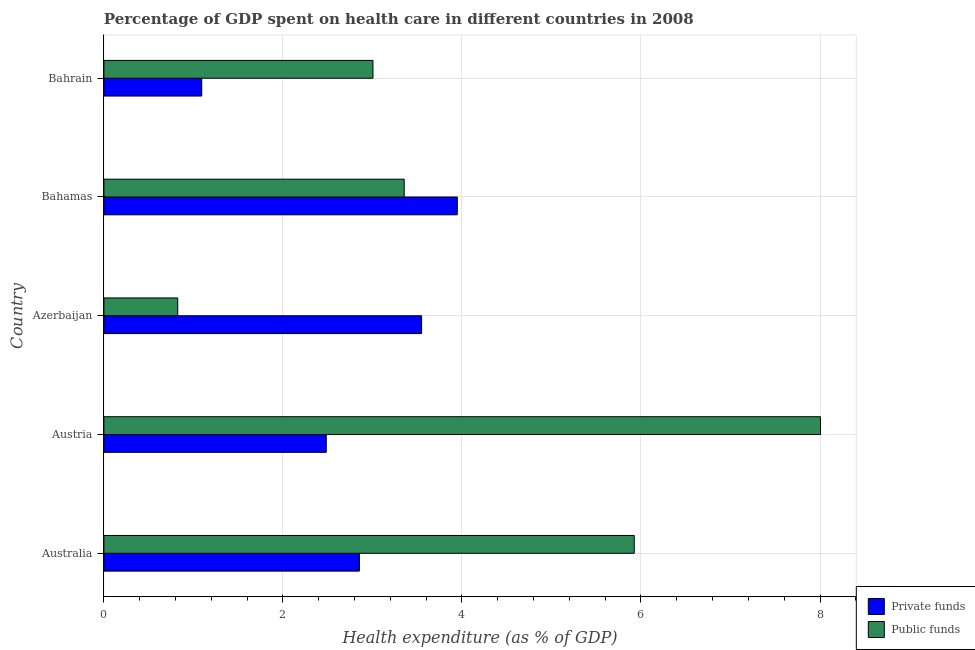How many groups of bars are there?
Your answer should be compact. 5. How many bars are there on the 5th tick from the bottom?
Provide a short and direct response. 2. What is the label of the 2nd group of bars from the top?
Provide a succinct answer. Bahamas. What is the amount of private funds spent in healthcare in Austria?
Your answer should be compact. 2.48. Across all countries, what is the maximum amount of private funds spent in healthcare?
Give a very brief answer. 3.95. Across all countries, what is the minimum amount of public funds spent in healthcare?
Offer a very short reply. 0.82. In which country was the amount of private funds spent in healthcare maximum?
Offer a terse response. Bahamas. In which country was the amount of public funds spent in healthcare minimum?
Offer a very short reply. Azerbaijan. What is the total amount of public funds spent in healthcare in the graph?
Offer a terse response. 21.12. What is the difference between the amount of private funds spent in healthcare in Australia and that in Bahrain?
Provide a succinct answer. 1.76. What is the difference between the amount of public funds spent in healthcare in Azerbaijan and the amount of private funds spent in healthcare in Bahamas?
Provide a succinct answer. -3.12. What is the average amount of public funds spent in healthcare per country?
Provide a short and direct response. 4.22. What is the difference between the amount of public funds spent in healthcare and amount of private funds spent in healthcare in Bahamas?
Your answer should be very brief. -0.59. In how many countries, is the amount of public funds spent in healthcare greater than 6 %?
Provide a short and direct response. 1. What is the ratio of the amount of public funds spent in healthcare in Azerbaijan to that in Bahamas?
Provide a succinct answer. 0.25. Is the difference between the amount of public funds spent in healthcare in Australia and Azerbaijan greater than the difference between the amount of private funds spent in healthcare in Australia and Azerbaijan?
Provide a succinct answer. Yes. What is the difference between the highest and the second highest amount of public funds spent in healthcare?
Provide a succinct answer. 2.08. What is the difference between the highest and the lowest amount of public funds spent in healthcare?
Provide a succinct answer. 7.18. In how many countries, is the amount of private funds spent in healthcare greater than the average amount of private funds spent in healthcare taken over all countries?
Offer a very short reply. 3. Is the sum of the amount of private funds spent in healthcare in Azerbaijan and Bahrain greater than the maximum amount of public funds spent in healthcare across all countries?
Give a very brief answer. No. What does the 2nd bar from the top in Austria represents?
Provide a short and direct response. Private funds. What does the 1st bar from the bottom in Bahrain represents?
Provide a succinct answer. Private funds. How many bars are there?
Make the answer very short. 10. How many countries are there in the graph?
Your response must be concise. 5. What is the difference between two consecutive major ticks on the X-axis?
Make the answer very short. 2. Are the values on the major ticks of X-axis written in scientific E-notation?
Ensure brevity in your answer.  No. How are the legend labels stacked?
Offer a terse response. Vertical. What is the title of the graph?
Provide a short and direct response. Percentage of GDP spent on health care in different countries in 2008. What is the label or title of the X-axis?
Make the answer very short. Health expenditure (as % of GDP). What is the Health expenditure (as % of GDP) of Private funds in Australia?
Make the answer very short. 2.85. What is the Health expenditure (as % of GDP) in Public funds in Australia?
Your response must be concise. 5.92. What is the Health expenditure (as % of GDP) in Private funds in Austria?
Keep it short and to the point. 2.48. What is the Health expenditure (as % of GDP) of Public funds in Austria?
Keep it short and to the point. 8.01. What is the Health expenditure (as % of GDP) of Private funds in Azerbaijan?
Your answer should be very brief. 3.55. What is the Health expenditure (as % of GDP) of Public funds in Azerbaijan?
Your answer should be compact. 0.82. What is the Health expenditure (as % of GDP) of Private funds in Bahamas?
Your response must be concise. 3.95. What is the Health expenditure (as % of GDP) of Public funds in Bahamas?
Your response must be concise. 3.35. What is the Health expenditure (as % of GDP) of Private funds in Bahrain?
Give a very brief answer. 1.09. What is the Health expenditure (as % of GDP) in Public funds in Bahrain?
Keep it short and to the point. 3.01. Across all countries, what is the maximum Health expenditure (as % of GDP) of Private funds?
Your answer should be very brief. 3.95. Across all countries, what is the maximum Health expenditure (as % of GDP) of Public funds?
Offer a terse response. 8.01. Across all countries, what is the minimum Health expenditure (as % of GDP) of Private funds?
Provide a short and direct response. 1.09. Across all countries, what is the minimum Health expenditure (as % of GDP) of Public funds?
Ensure brevity in your answer.  0.82. What is the total Health expenditure (as % of GDP) of Private funds in the graph?
Provide a succinct answer. 13.93. What is the total Health expenditure (as % of GDP) of Public funds in the graph?
Provide a short and direct response. 21.12. What is the difference between the Health expenditure (as % of GDP) in Private funds in Australia and that in Austria?
Ensure brevity in your answer.  0.37. What is the difference between the Health expenditure (as % of GDP) of Public funds in Australia and that in Austria?
Offer a terse response. -2.08. What is the difference between the Health expenditure (as % of GDP) of Private funds in Australia and that in Azerbaijan?
Your response must be concise. -0.69. What is the difference between the Health expenditure (as % of GDP) in Public funds in Australia and that in Azerbaijan?
Provide a succinct answer. 5.1. What is the difference between the Health expenditure (as % of GDP) in Private funds in Australia and that in Bahamas?
Offer a very short reply. -1.09. What is the difference between the Health expenditure (as % of GDP) of Public funds in Australia and that in Bahamas?
Offer a terse response. 2.57. What is the difference between the Health expenditure (as % of GDP) in Private funds in Australia and that in Bahrain?
Offer a terse response. 1.76. What is the difference between the Health expenditure (as % of GDP) of Public funds in Australia and that in Bahrain?
Keep it short and to the point. 2.92. What is the difference between the Health expenditure (as % of GDP) of Private funds in Austria and that in Azerbaijan?
Offer a very short reply. -1.07. What is the difference between the Health expenditure (as % of GDP) in Public funds in Austria and that in Azerbaijan?
Make the answer very short. 7.18. What is the difference between the Health expenditure (as % of GDP) in Private funds in Austria and that in Bahamas?
Offer a very short reply. -1.46. What is the difference between the Health expenditure (as % of GDP) in Public funds in Austria and that in Bahamas?
Your answer should be compact. 4.65. What is the difference between the Health expenditure (as % of GDP) of Private funds in Austria and that in Bahrain?
Provide a short and direct response. 1.39. What is the difference between the Health expenditure (as % of GDP) in Public funds in Austria and that in Bahrain?
Keep it short and to the point. 5. What is the difference between the Health expenditure (as % of GDP) of Private funds in Azerbaijan and that in Bahamas?
Provide a succinct answer. -0.4. What is the difference between the Health expenditure (as % of GDP) of Public funds in Azerbaijan and that in Bahamas?
Your answer should be very brief. -2.53. What is the difference between the Health expenditure (as % of GDP) of Private funds in Azerbaijan and that in Bahrain?
Keep it short and to the point. 2.46. What is the difference between the Health expenditure (as % of GDP) in Public funds in Azerbaijan and that in Bahrain?
Offer a terse response. -2.18. What is the difference between the Health expenditure (as % of GDP) in Private funds in Bahamas and that in Bahrain?
Offer a terse response. 2.85. What is the difference between the Health expenditure (as % of GDP) of Public funds in Bahamas and that in Bahrain?
Your answer should be compact. 0.35. What is the difference between the Health expenditure (as % of GDP) in Private funds in Australia and the Health expenditure (as % of GDP) in Public funds in Austria?
Ensure brevity in your answer.  -5.15. What is the difference between the Health expenditure (as % of GDP) in Private funds in Australia and the Health expenditure (as % of GDP) in Public funds in Azerbaijan?
Provide a succinct answer. 2.03. What is the difference between the Health expenditure (as % of GDP) in Private funds in Australia and the Health expenditure (as % of GDP) in Public funds in Bahamas?
Give a very brief answer. -0.5. What is the difference between the Health expenditure (as % of GDP) in Private funds in Australia and the Health expenditure (as % of GDP) in Public funds in Bahrain?
Make the answer very short. -0.15. What is the difference between the Health expenditure (as % of GDP) in Private funds in Austria and the Health expenditure (as % of GDP) in Public funds in Azerbaijan?
Provide a short and direct response. 1.66. What is the difference between the Health expenditure (as % of GDP) of Private funds in Austria and the Health expenditure (as % of GDP) of Public funds in Bahamas?
Give a very brief answer. -0.87. What is the difference between the Health expenditure (as % of GDP) in Private funds in Austria and the Health expenditure (as % of GDP) in Public funds in Bahrain?
Your answer should be compact. -0.52. What is the difference between the Health expenditure (as % of GDP) in Private funds in Azerbaijan and the Health expenditure (as % of GDP) in Public funds in Bahamas?
Your response must be concise. 0.19. What is the difference between the Health expenditure (as % of GDP) of Private funds in Azerbaijan and the Health expenditure (as % of GDP) of Public funds in Bahrain?
Provide a succinct answer. 0.54. What is the difference between the Health expenditure (as % of GDP) of Private funds in Bahamas and the Health expenditure (as % of GDP) of Public funds in Bahrain?
Offer a very short reply. 0.94. What is the average Health expenditure (as % of GDP) of Private funds per country?
Offer a very short reply. 2.79. What is the average Health expenditure (as % of GDP) of Public funds per country?
Provide a succinct answer. 4.22. What is the difference between the Health expenditure (as % of GDP) in Private funds and Health expenditure (as % of GDP) in Public funds in Australia?
Provide a short and direct response. -3.07. What is the difference between the Health expenditure (as % of GDP) of Private funds and Health expenditure (as % of GDP) of Public funds in Austria?
Provide a succinct answer. -5.52. What is the difference between the Health expenditure (as % of GDP) of Private funds and Health expenditure (as % of GDP) of Public funds in Azerbaijan?
Give a very brief answer. 2.72. What is the difference between the Health expenditure (as % of GDP) of Private funds and Health expenditure (as % of GDP) of Public funds in Bahamas?
Make the answer very short. 0.59. What is the difference between the Health expenditure (as % of GDP) of Private funds and Health expenditure (as % of GDP) of Public funds in Bahrain?
Your answer should be compact. -1.91. What is the ratio of the Health expenditure (as % of GDP) of Private funds in Australia to that in Austria?
Make the answer very short. 1.15. What is the ratio of the Health expenditure (as % of GDP) of Public funds in Australia to that in Austria?
Give a very brief answer. 0.74. What is the ratio of the Health expenditure (as % of GDP) of Private funds in Australia to that in Azerbaijan?
Provide a short and direct response. 0.8. What is the ratio of the Health expenditure (as % of GDP) in Public funds in Australia to that in Azerbaijan?
Make the answer very short. 7.18. What is the ratio of the Health expenditure (as % of GDP) of Private funds in Australia to that in Bahamas?
Your response must be concise. 0.72. What is the ratio of the Health expenditure (as % of GDP) of Public funds in Australia to that in Bahamas?
Ensure brevity in your answer.  1.77. What is the ratio of the Health expenditure (as % of GDP) in Private funds in Australia to that in Bahrain?
Your answer should be compact. 2.61. What is the ratio of the Health expenditure (as % of GDP) in Public funds in Australia to that in Bahrain?
Ensure brevity in your answer.  1.97. What is the ratio of the Health expenditure (as % of GDP) of Private funds in Austria to that in Azerbaijan?
Your answer should be compact. 0.7. What is the ratio of the Health expenditure (as % of GDP) of Public funds in Austria to that in Azerbaijan?
Provide a short and direct response. 9.71. What is the ratio of the Health expenditure (as % of GDP) of Private funds in Austria to that in Bahamas?
Offer a very short reply. 0.63. What is the ratio of the Health expenditure (as % of GDP) of Public funds in Austria to that in Bahamas?
Your answer should be compact. 2.39. What is the ratio of the Health expenditure (as % of GDP) of Private funds in Austria to that in Bahrain?
Offer a terse response. 2.27. What is the ratio of the Health expenditure (as % of GDP) in Public funds in Austria to that in Bahrain?
Keep it short and to the point. 2.66. What is the ratio of the Health expenditure (as % of GDP) in Private funds in Azerbaijan to that in Bahamas?
Your answer should be very brief. 0.9. What is the ratio of the Health expenditure (as % of GDP) in Public funds in Azerbaijan to that in Bahamas?
Provide a short and direct response. 0.25. What is the ratio of the Health expenditure (as % of GDP) of Private funds in Azerbaijan to that in Bahrain?
Offer a very short reply. 3.25. What is the ratio of the Health expenditure (as % of GDP) in Public funds in Azerbaijan to that in Bahrain?
Ensure brevity in your answer.  0.27. What is the ratio of the Health expenditure (as % of GDP) in Private funds in Bahamas to that in Bahrain?
Your response must be concise. 3.61. What is the ratio of the Health expenditure (as % of GDP) of Public funds in Bahamas to that in Bahrain?
Ensure brevity in your answer.  1.12. What is the difference between the highest and the second highest Health expenditure (as % of GDP) of Private funds?
Offer a terse response. 0.4. What is the difference between the highest and the second highest Health expenditure (as % of GDP) in Public funds?
Give a very brief answer. 2.08. What is the difference between the highest and the lowest Health expenditure (as % of GDP) in Private funds?
Offer a terse response. 2.85. What is the difference between the highest and the lowest Health expenditure (as % of GDP) of Public funds?
Offer a terse response. 7.18. 